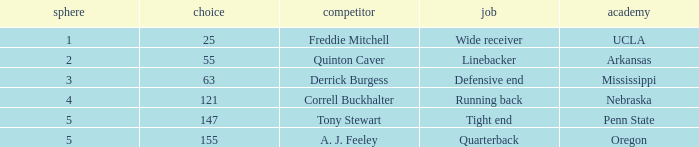What position did a. j. feeley play who was picked in round 5? Quarterback. 